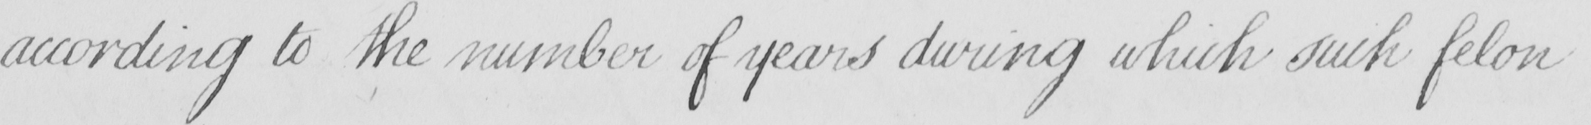Can you tell me what this handwritten text says? according to the number of years during which such felon 